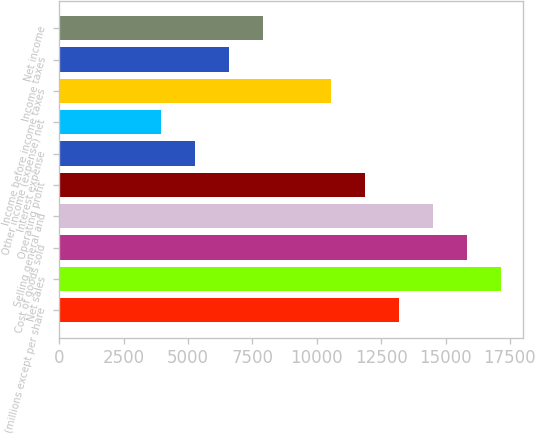Convert chart to OTSL. <chart><loc_0><loc_0><loc_500><loc_500><bar_chart><fcel>(millions except per share<fcel>Net sales<fcel>Cost of goods sold<fcel>Selling general and<fcel>Operating profit<fcel>Interest expense<fcel>Other income (expense) net<fcel>Income before income taxes<fcel>Income taxes<fcel>Net income<nl><fcel>13198<fcel>17156.9<fcel>15837.2<fcel>14517.6<fcel>11878.3<fcel>5280.19<fcel>3960.56<fcel>10558.7<fcel>6599.82<fcel>7919.45<nl></chart> 